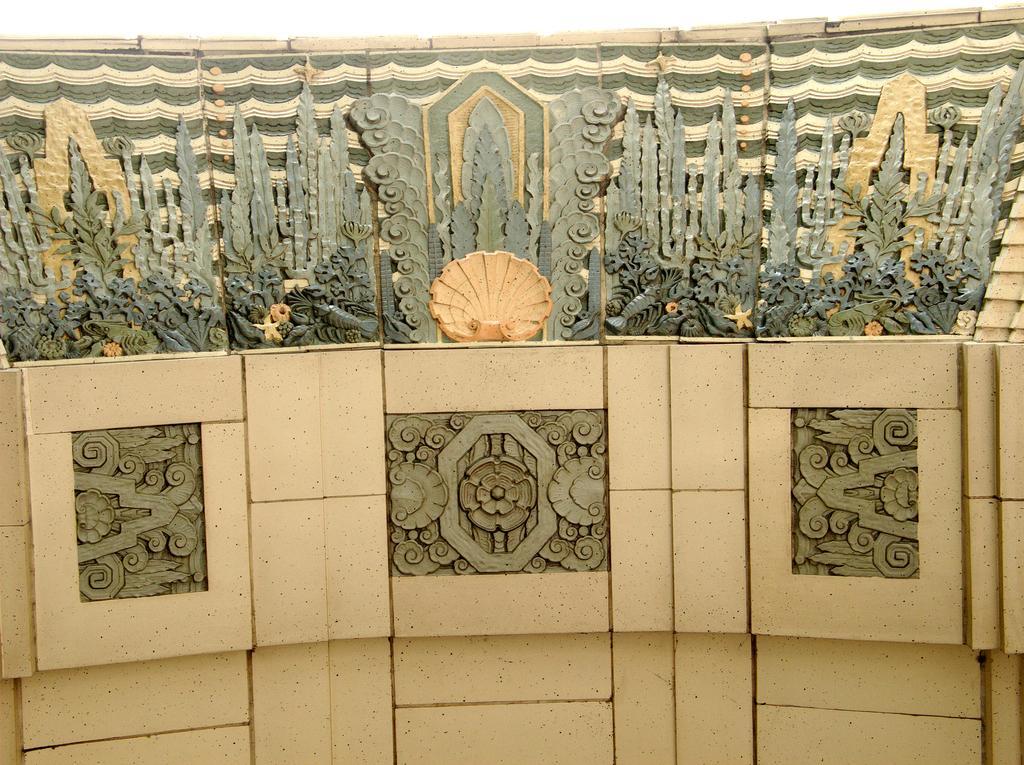Could you give a brief overview of what you see in this image? There are different types of tiles are attached to the wall, some of them were plain and some of them are with different designs. 